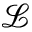Convert formula to latex. <formula><loc_0><loc_0><loc_500><loc_500>\mathcal { L }</formula> 